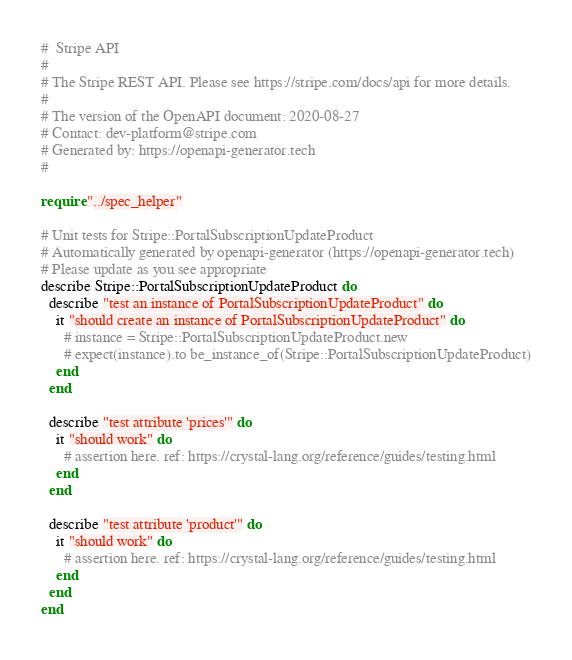Convert code to text. <code><loc_0><loc_0><loc_500><loc_500><_Crystal_>#  Stripe API
#
# The Stripe REST API. Please see https://stripe.com/docs/api for more details.
#
# The version of the OpenAPI document: 2020-08-27
# Contact: dev-platform@stripe.com
# Generated by: https://openapi-generator.tech
#

require "../spec_helper"

# Unit tests for Stripe::PortalSubscriptionUpdateProduct
# Automatically generated by openapi-generator (https://openapi-generator.tech)
# Please update as you see appropriate
describe Stripe::PortalSubscriptionUpdateProduct do
  describe "test an instance of PortalSubscriptionUpdateProduct" do
    it "should create an instance of PortalSubscriptionUpdateProduct" do
      # instance = Stripe::PortalSubscriptionUpdateProduct.new
      # expect(instance).to be_instance_of(Stripe::PortalSubscriptionUpdateProduct)
    end
  end

  describe "test attribute 'prices'" do
    it "should work" do
      # assertion here. ref: https://crystal-lang.org/reference/guides/testing.html
    end
  end

  describe "test attribute 'product'" do
    it "should work" do
      # assertion here. ref: https://crystal-lang.org/reference/guides/testing.html
    end
  end
end
</code> 